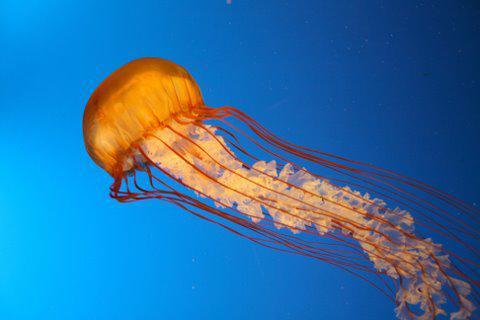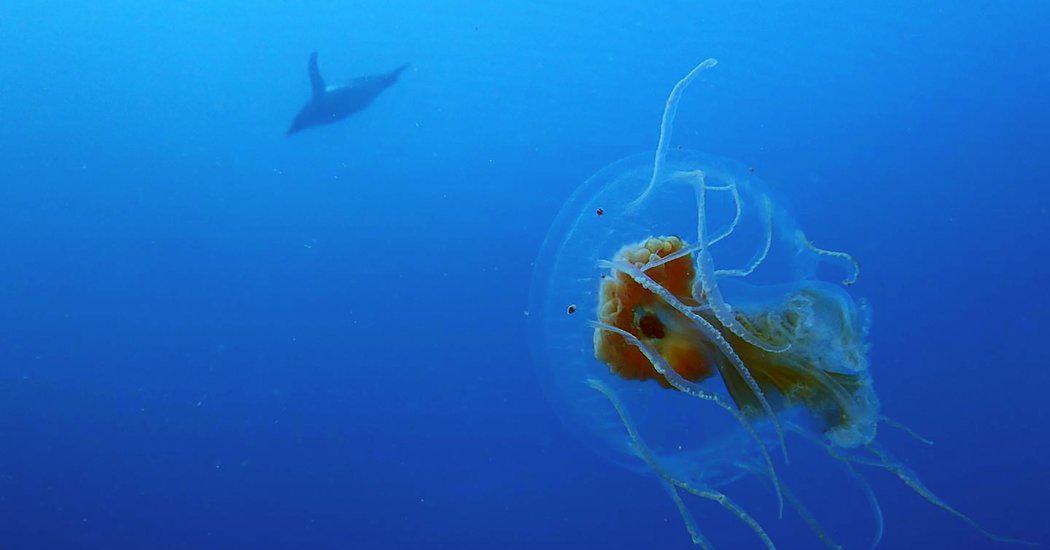The first image is the image on the left, the second image is the image on the right. For the images shown, is this caption "The left image features one orange-capped jellyfish moving horizontally with threadlike and ruffled-look tentacles trailing behind it." true? Answer yes or no. Yes. The first image is the image on the left, the second image is the image on the right. For the images displayed, is the sentence "At least one jellyfish has a polka dot body." factually correct? Answer yes or no. No. 